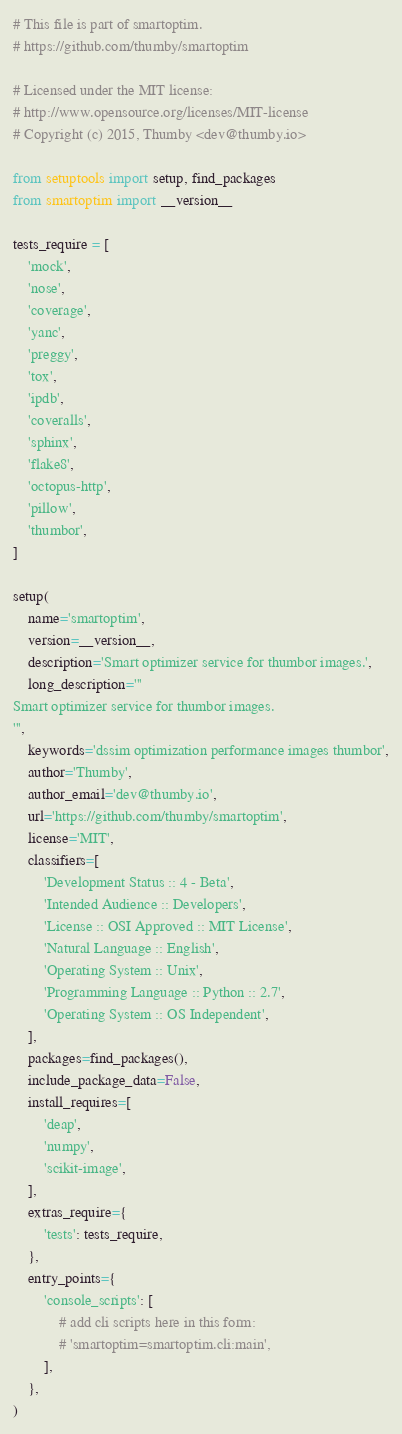Convert code to text. <code><loc_0><loc_0><loc_500><loc_500><_Python_># This file is part of smartoptim.
# https://github.com/thumby/smartoptim

# Licensed under the MIT license:
# http://www.opensource.org/licenses/MIT-license
# Copyright (c) 2015, Thumby <dev@thumby.io>

from setuptools import setup, find_packages
from smartoptim import __version__

tests_require = [
    'mock',
    'nose',
    'coverage',
    'yanc',
    'preggy',
    'tox',
    'ipdb',
    'coveralls',
    'sphinx',
    'flake8',
    'octopus-http',
    'pillow',
    'thumbor',
]

setup(
    name='smartoptim',
    version=__version__,
    description='Smart optimizer service for thumbor images.',
    long_description='''
Smart optimizer service for thumbor images.
''',
    keywords='dssim optimization performance images thumbor',
    author='Thumby',
    author_email='dev@thumby.io',
    url='https://github.com/thumby/smartoptim',
    license='MIT',
    classifiers=[
        'Development Status :: 4 - Beta',
        'Intended Audience :: Developers',
        'License :: OSI Approved :: MIT License',
        'Natural Language :: English',
        'Operating System :: Unix',
        'Programming Language :: Python :: 2.7',
        'Operating System :: OS Independent',
    ],
    packages=find_packages(),
    include_package_data=False,
    install_requires=[
        'deap',
        'numpy',
        'scikit-image',
    ],
    extras_require={
        'tests': tests_require,
    },
    entry_points={
        'console_scripts': [
            # add cli scripts here in this form:
            # 'smartoptim=smartoptim.cli:main',
        ],
    },
)
</code> 